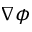Convert formula to latex. <formula><loc_0><loc_0><loc_500><loc_500>\nabla \phi</formula> 